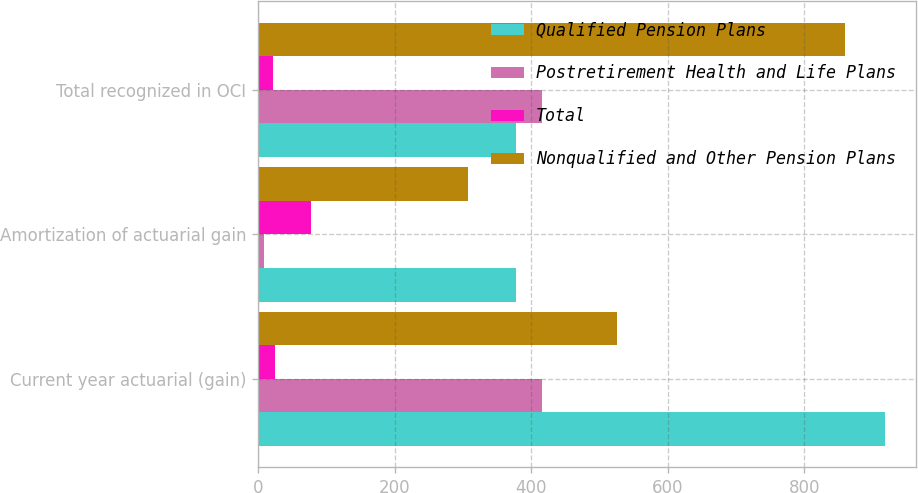Convert chart. <chart><loc_0><loc_0><loc_500><loc_500><stacked_bar_chart><ecel><fcel>Current year actuarial (gain)<fcel>Amortization of actuarial gain<fcel>Total recognized in OCI<nl><fcel>Qualified Pension Plans<fcel>918<fcel>377<fcel>377<nl><fcel>Postretirement Health and Life Plans<fcel>416<fcel>8<fcel>416<nl><fcel>Total<fcel>24<fcel>77<fcel>22<nl><fcel>Nonqualified and Other Pension Plans<fcel>526<fcel>308<fcel>860<nl></chart> 